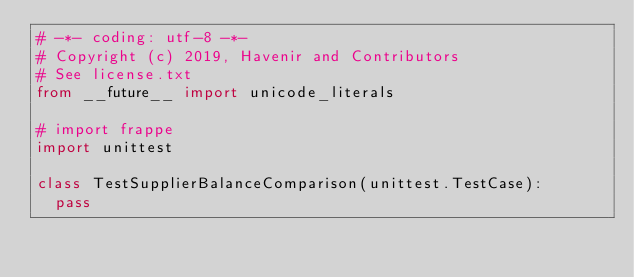<code> <loc_0><loc_0><loc_500><loc_500><_Python_># -*- coding: utf-8 -*-
# Copyright (c) 2019, Havenir and Contributors
# See license.txt
from __future__ import unicode_literals

# import frappe
import unittest

class TestSupplierBalanceComparison(unittest.TestCase):
	pass
</code> 